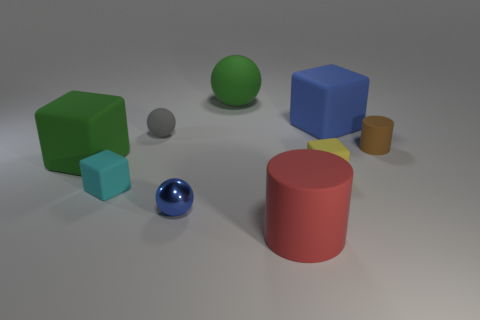Subtract 1 blocks. How many blocks are left? 3 Add 1 large rubber cylinders. How many objects exist? 10 Subtract all cubes. How many objects are left? 5 Subtract all purple blocks. Subtract all blue rubber cubes. How many objects are left? 8 Add 5 tiny gray matte objects. How many tiny gray matte objects are left? 6 Add 5 big green rubber spheres. How many big green rubber spheres exist? 6 Subtract 1 brown cylinders. How many objects are left? 8 